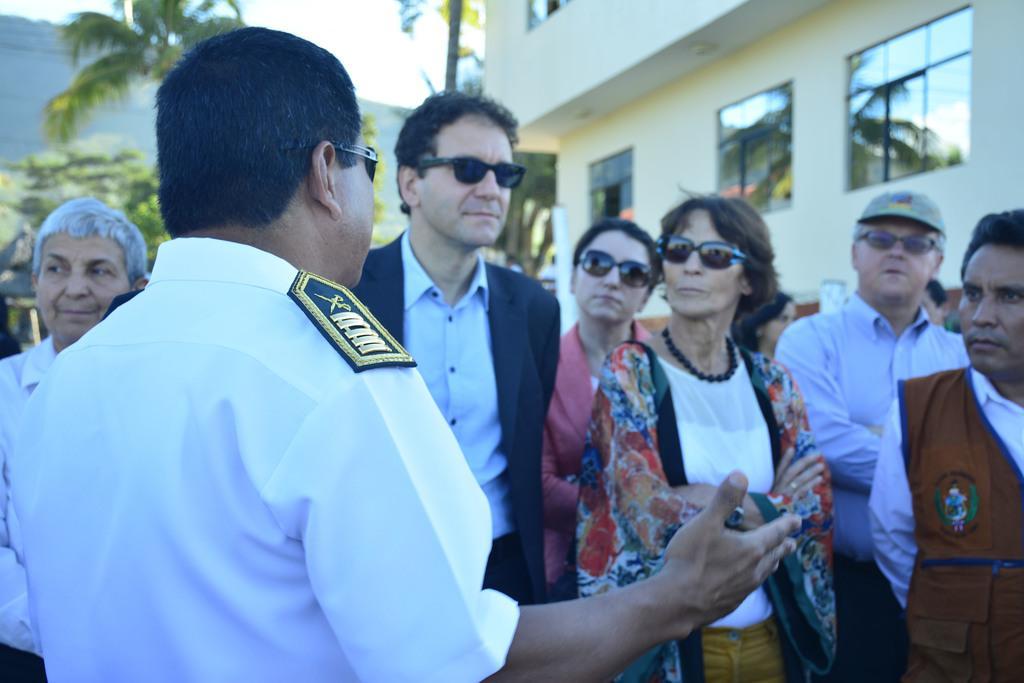In one or two sentences, can you explain what this image depicts? In this picture I can see few people standing and few people wore sunglasses and I can see building and trees and a hill and I can see a cloudy sky. 